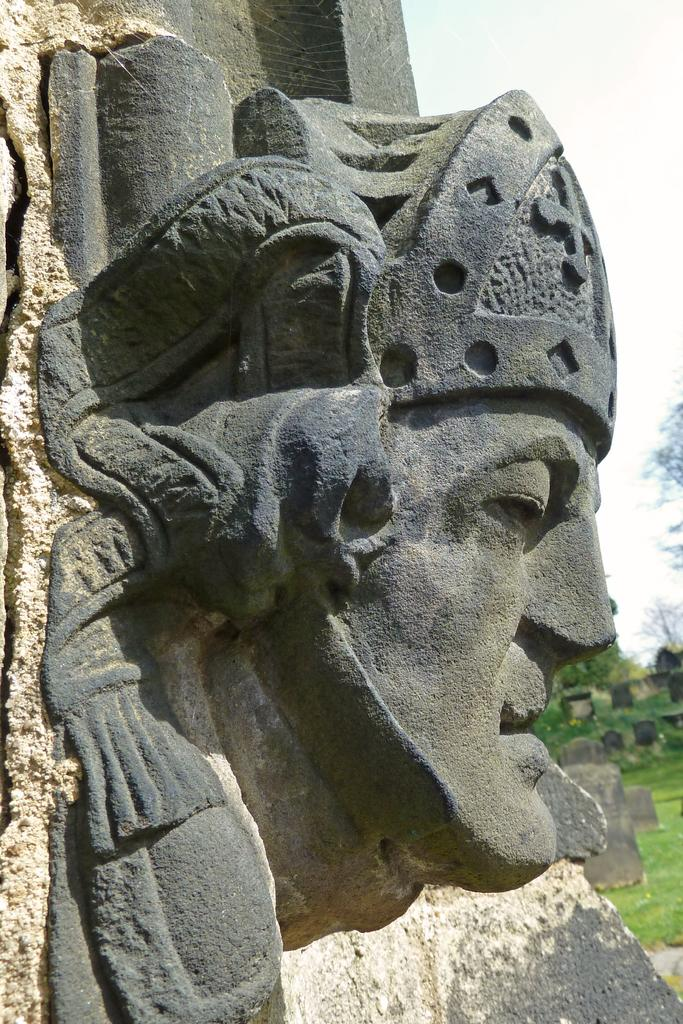What is the main subject of the image? There is a statue in the image. Can you describe the statue? The statue is in the shape of a man. Where is the bucket located in the image? There is no bucket present in the image. What type of seed can be seen growing near the statue? There is no seed present in the image. 